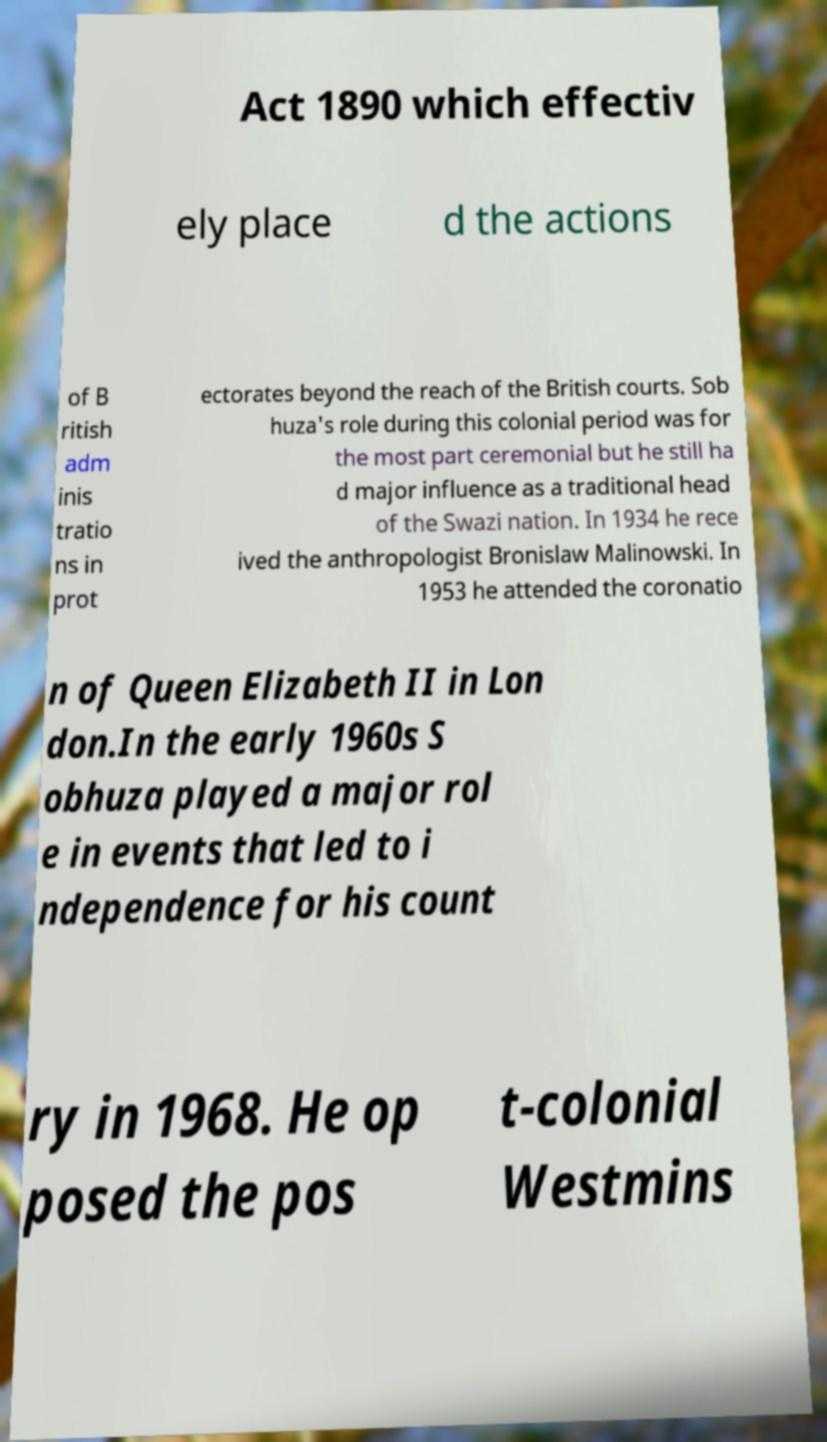What messages or text are displayed in this image? I need them in a readable, typed format. Act 1890 which effectiv ely place d the actions of B ritish adm inis tratio ns in prot ectorates beyond the reach of the British courts. Sob huza's role during this colonial period was for the most part ceremonial but he still ha d major influence as a traditional head of the Swazi nation. In 1934 he rece ived the anthropologist Bronislaw Malinowski. In 1953 he attended the coronatio n of Queen Elizabeth II in Lon don.In the early 1960s S obhuza played a major rol e in events that led to i ndependence for his count ry in 1968. He op posed the pos t-colonial Westmins 